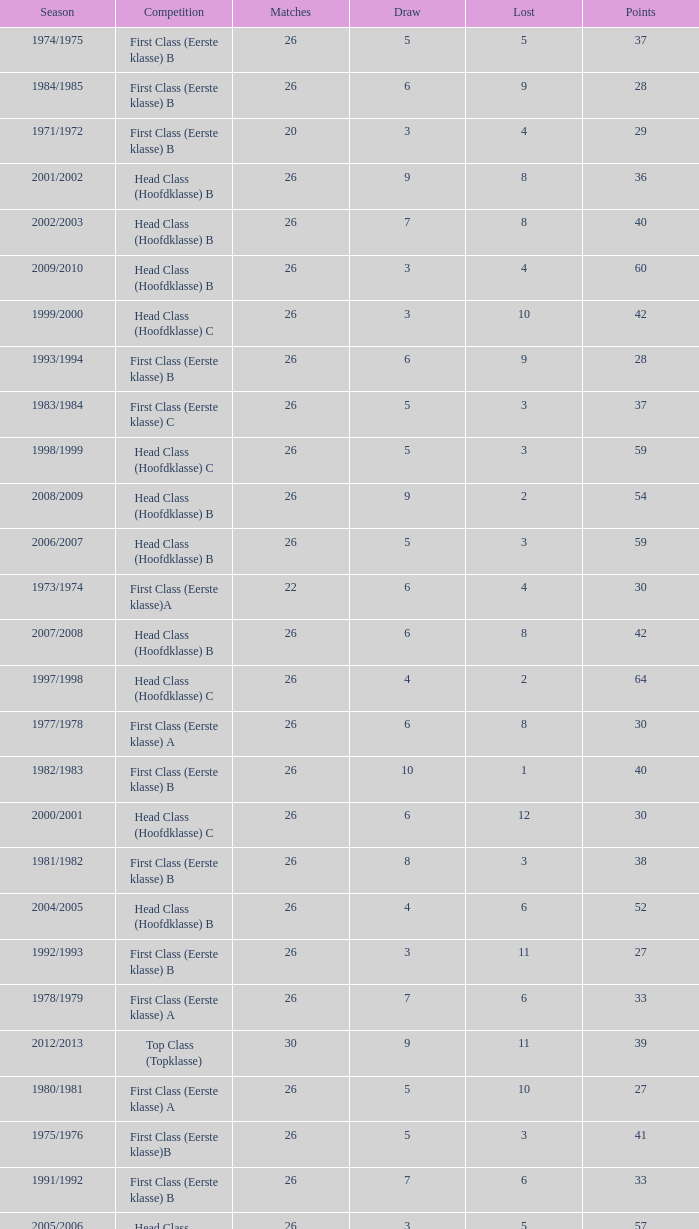What competition has a score greater than 30, a draw less than 5, and a loss larger than 10? Top Class (Topklasse). 